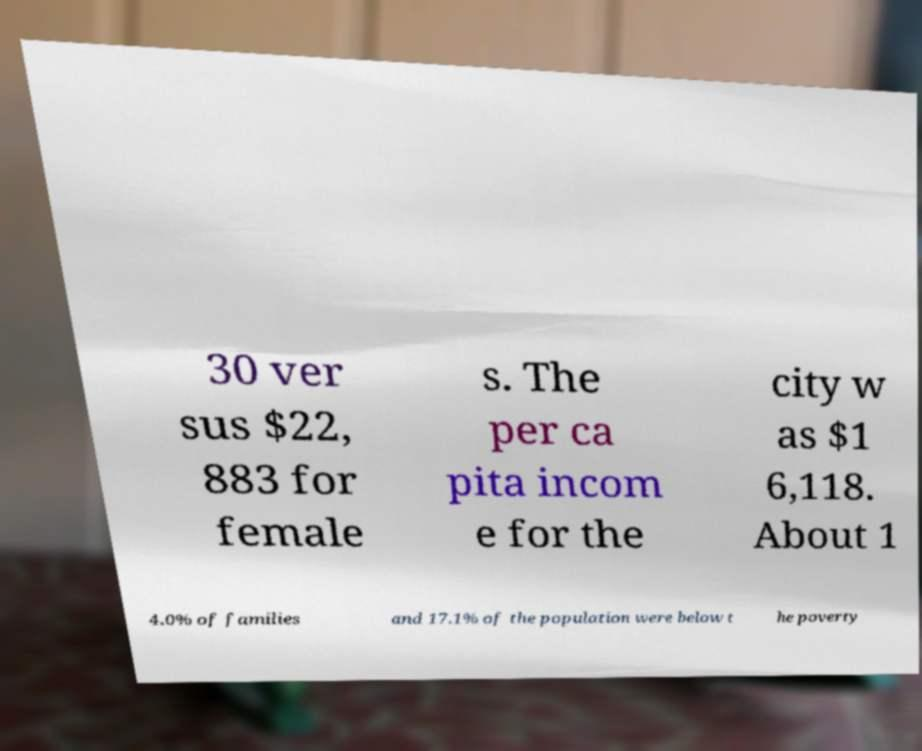Please read and relay the text visible in this image. What does it say? 30 ver sus $22, 883 for female s. The per ca pita incom e for the city w as $1 6,118. About 1 4.0% of families and 17.1% of the population were below t he poverty 